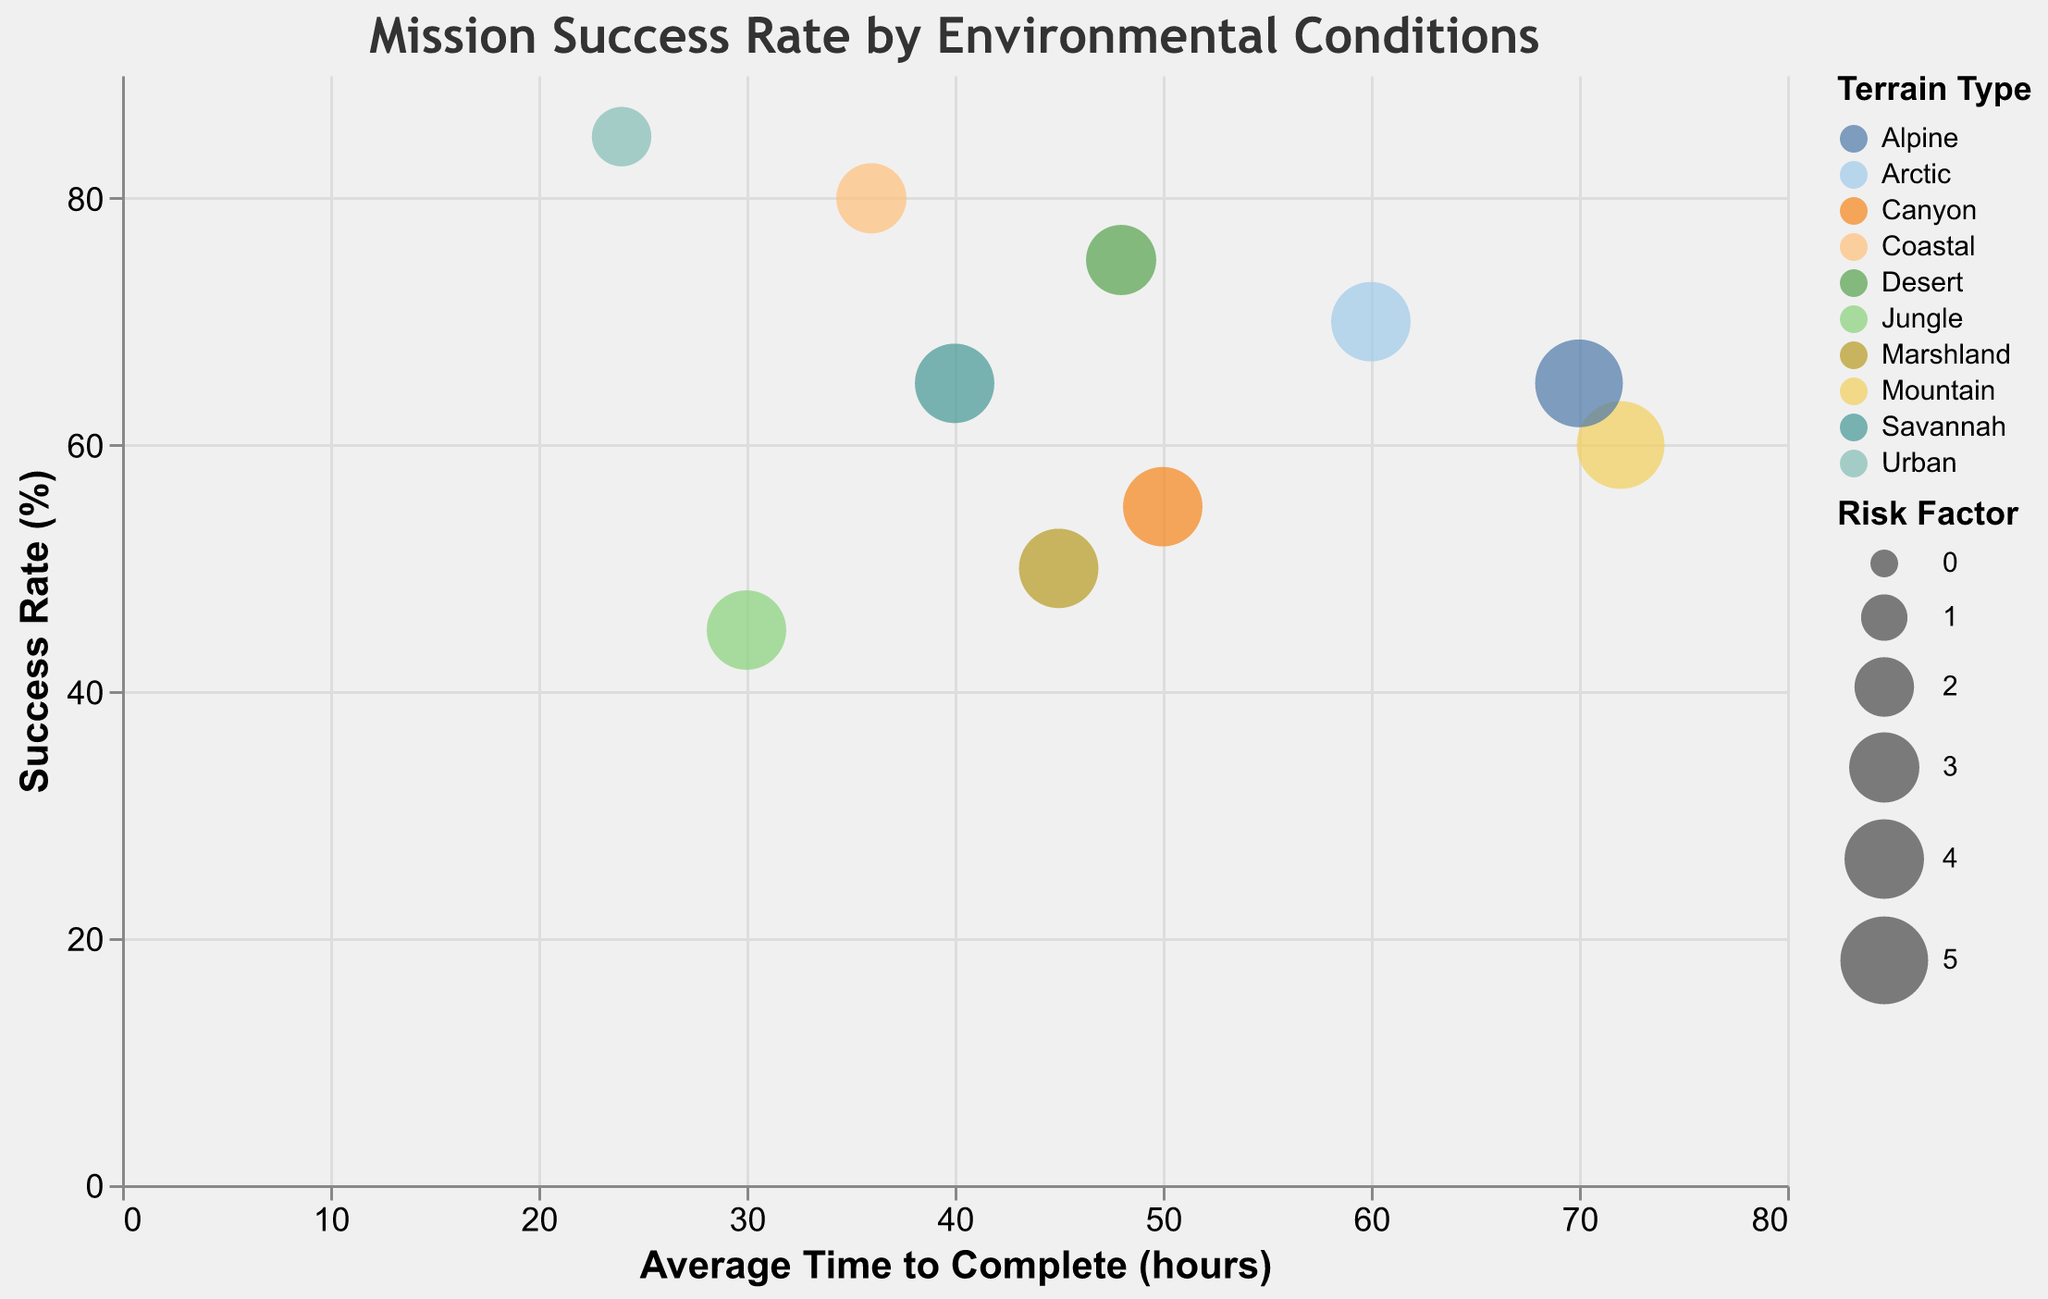What is the title of the figure? The title is located at the top of the figure and it reads "Mission Success Rate by Environmental Conditions".
Answer: Mission Success Rate by Environmental Conditions How many terrain types are represented in the figure? Each bubble in the figure is colored differently to represent each terrain type. By counting these unique colors, we can determine the number of terrain types.
Answer: 10 Which mission has the highest success rate? The y-axis indicates the success rate. The mission with the highest bubble along the y-axis is the one with the highest success rate. In this case, it is the bubble for "Operation Urban Saber".
Answer: Operation Urban Saber What is the average time to complete for "Operation Coastal Guard"? Hovering over or clicking the bubble for "Operation Coastal Guard" displays its tooltip, revealing that the average time to complete is 36 hours.
Answer: 36 hours What is the relationship between "Operation Desert Storm" and "Operation Mountain Eagle" in terms of success rate and average time to complete? Compare the positions of the bubbles along the x and y axes. "Operation Desert Storm" has a higher success rate at 75% and a lesser average time to complete at 48 hours, whereas "Operation Mountain Eagle" has a success rate of 60% and a longer average time to complete at 72 hours.
Answer: "Operation Desert Storm" has a higher success rate and a shorter average time to complete than "Operation Mountain Eagle" Which mission has the largest risk factor and what is its terrain type? The size of the bubbles represents the risk factor. The largest bubble corresponds to "Operation Mountain Eagle" with a risk factor of 5. Its terrain type is Mountain.
Answer: Operation Mountain Eagle, Mountain What is the difference in success rates between "Operation Jungle Fury" and "Operation Coastal Guard"? "Operation Jungle Fury" has a success rate of 45%, and "Operation Coastal Guard" has a success rate of 80%. The difference is calculated as 80% - 45% = 35%.
Answer: 35% Which terrain type has the highest average risk factor among its missions, and what are the missions? By examining the bubble sizes, which represent the risk factor, and comparing the average size for each terrain type, "Mountain" and "Alpine" both have the highest average risk factor of 5. The missions are "Operation Mountain Eagle" (Mountain) and "Operation Alpine Watch" (Alpine).
Answer: Mountain and Alpine; Operation Mountain Eagle and Operation Alpine Watch Which mission has the shortest average time to complete and what is its success rate and risk factor? The x-axis represents the average time to complete. The leftmost bubble corresponds to "Operation Urban Saber" which has the shortest time to complete at 24 hours. Its success rate is 85%, and its risk factor is 2.
Answer: Operation Urban Saber, 85%, 2 